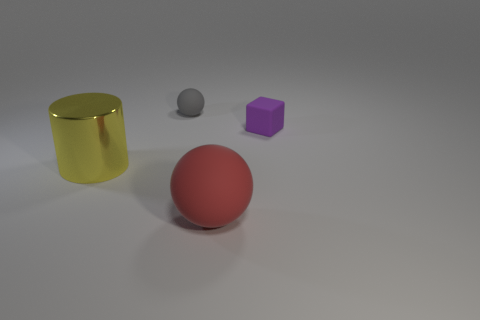Is there anything else that is the same shape as the purple object?
Provide a succinct answer. No. Is the number of small things behind the tiny rubber block greater than the number of purple matte cubes that are left of the tiny gray rubber object?
Give a very brief answer. Yes. There is a thing that is both on the right side of the small rubber ball and behind the big metallic cylinder; what is its shape?
Make the answer very short. Cube. What is the shape of the large thing that is behind the large red sphere?
Your answer should be compact. Cylinder. There is a sphere behind the small matte thing right of the matte ball that is behind the tiny cube; how big is it?
Provide a succinct answer. Small. Does the red rubber object have the same shape as the gray rubber thing?
Offer a terse response. Yes. There is a matte object that is both in front of the gray thing and to the left of the purple thing; how big is it?
Your answer should be very brief. Large. What is the material of the object that is left of the tiny thing behind the tiny purple block?
Provide a succinct answer. Metal. There is a big red thing; is it the same shape as the object that is behind the small purple rubber thing?
Your answer should be compact. Yes. How many metallic objects are balls or yellow objects?
Give a very brief answer. 1. 